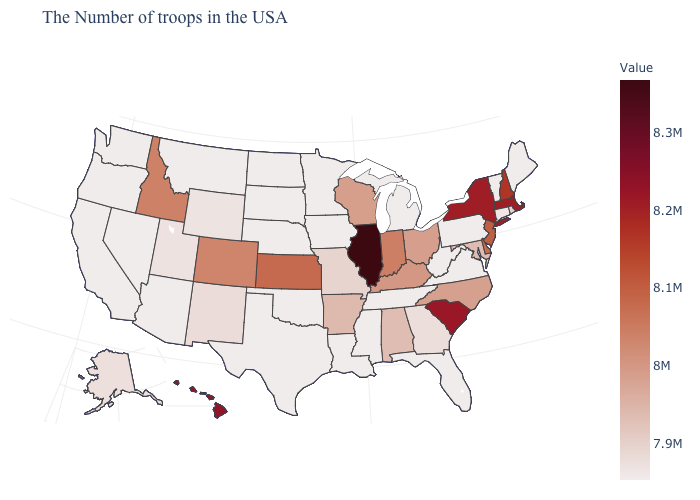Does South Dakota have the lowest value in the MidWest?
Quick response, please. Yes. Does Alaska have the highest value in the West?
Answer briefly. No. Does Illinois have the highest value in the USA?
Give a very brief answer. Yes. 